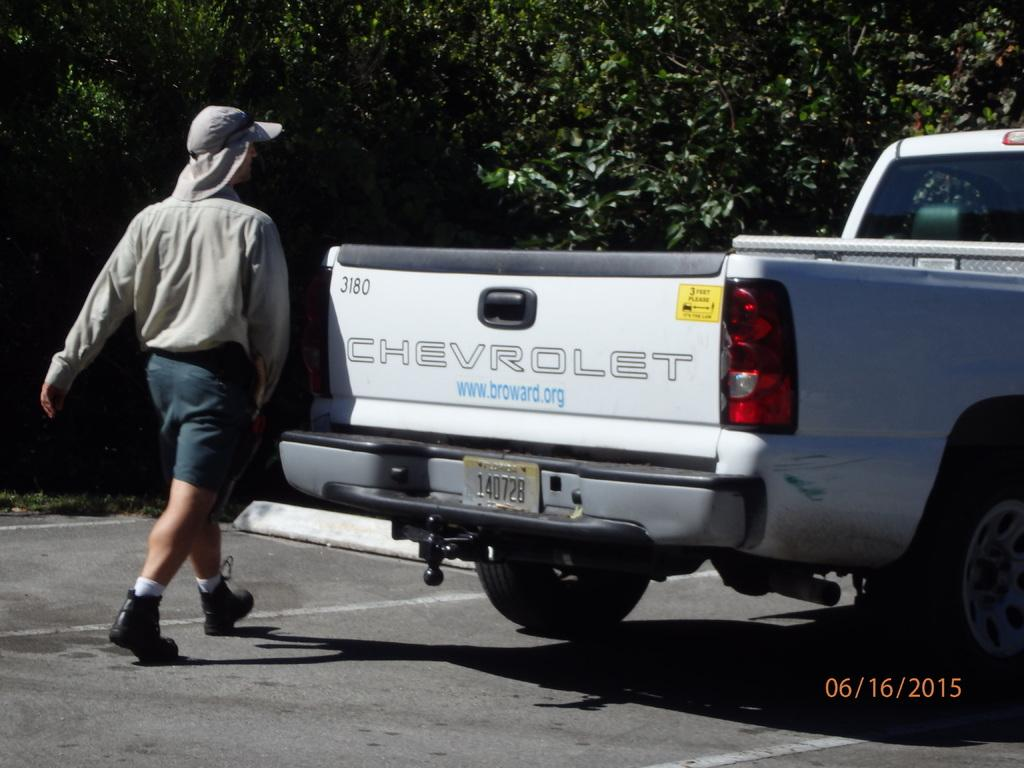What is the main subject in the image? There is a vehicle in the image. What else can be seen in the image besides the vehicle? There is a person walking in the image. What is visible in the background of the image? There are trees in the background of the image. What color are the trees in the image? The trees are green in color. What type of mint is growing on the person's head in the image? There is no mint or any plant growing on the person's head in the image. 